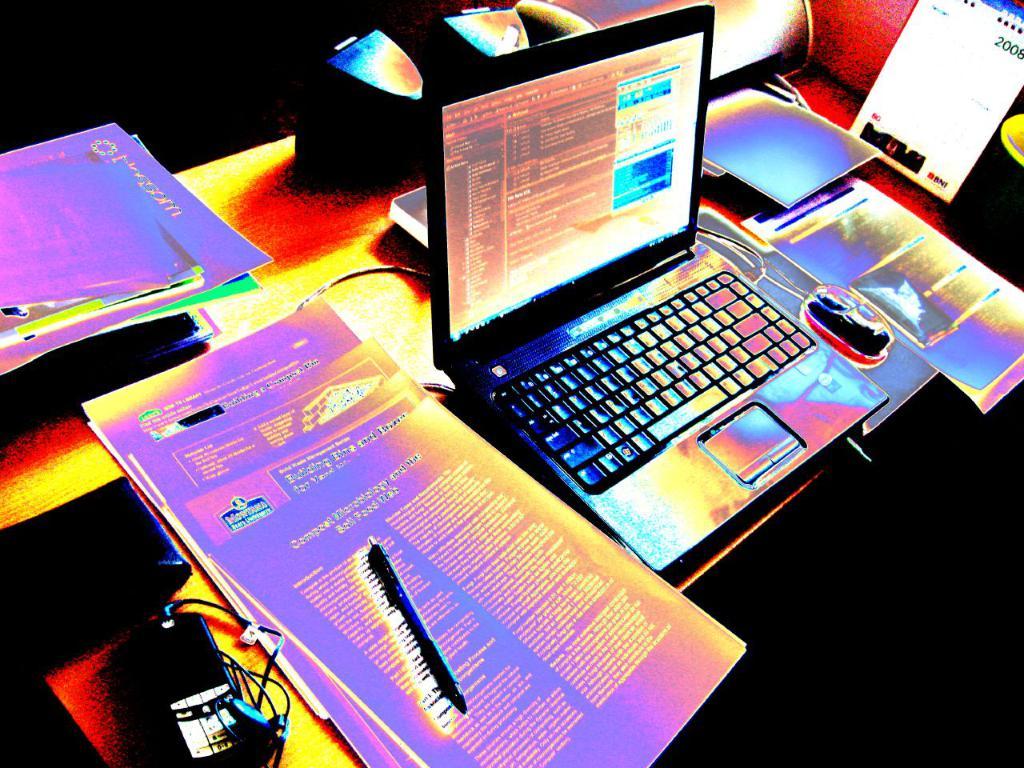What year is it?
Offer a terse response. Unanswerable. What three letters are on the bottom right on the calendar?
Keep it short and to the point. Bni. 